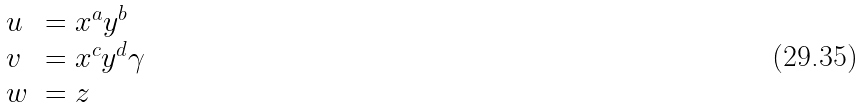Convert formula to latex. <formula><loc_0><loc_0><loc_500><loc_500>\begin{array} { l l } u & = x ^ { a } y ^ { b } \\ v & = x ^ { c } y ^ { d } \gamma \\ w & = z \end{array}</formula> 